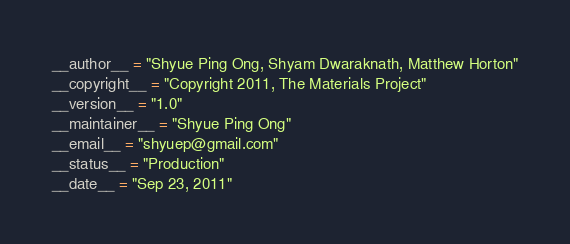Convert code to text. <code><loc_0><loc_0><loc_500><loc_500><_Python_>__author__ = "Shyue Ping Ong, Shyam Dwaraknath, Matthew Horton"
__copyright__ = "Copyright 2011, The Materials Project"
__version__ = "1.0"
__maintainer__ = "Shyue Ping Ong"
__email__ = "shyuep@gmail.com"
__status__ = "Production"
__date__ = "Sep 23, 2011"
</code> 